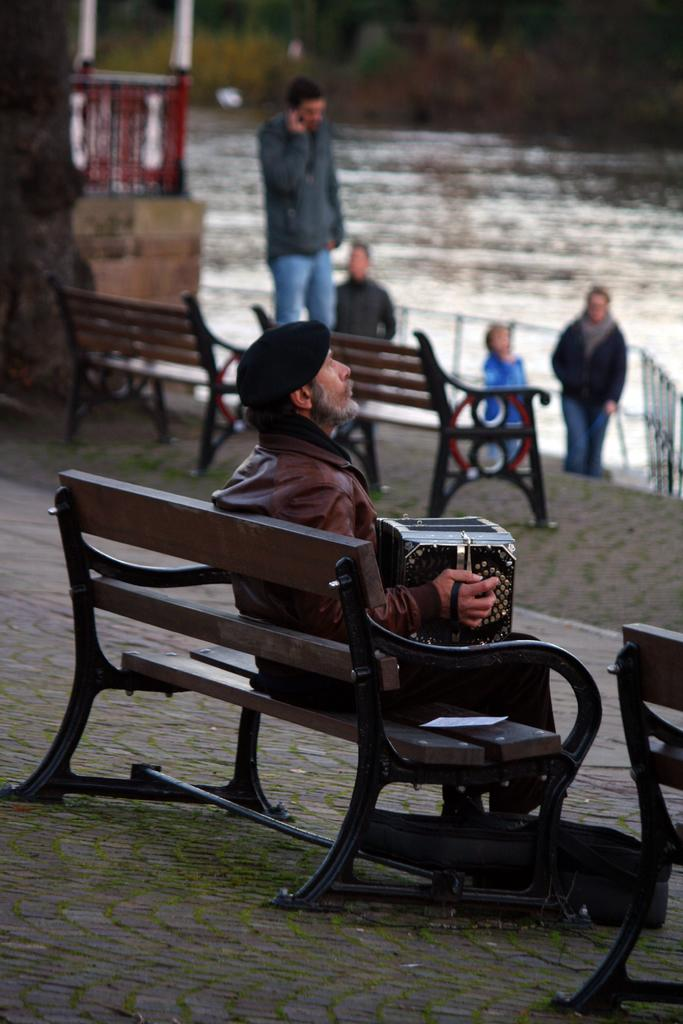What is the main subject of the image? There is a person in the image. What is the person wearing? The person is wearing a jacket and a cap. What is the person holding? The person is holding an accordion. Where is the person sitting? The person is sitting on a bench. What can be seen in the background of the image? There are many benches, persons, water, and a building visible in the background of the image. How many cows can be seen grazing near the river in the image? There are no cows or rivers present in the image. What type of seed is being planted by the person in the image? There is no seed or planting activity depicted in the image. 